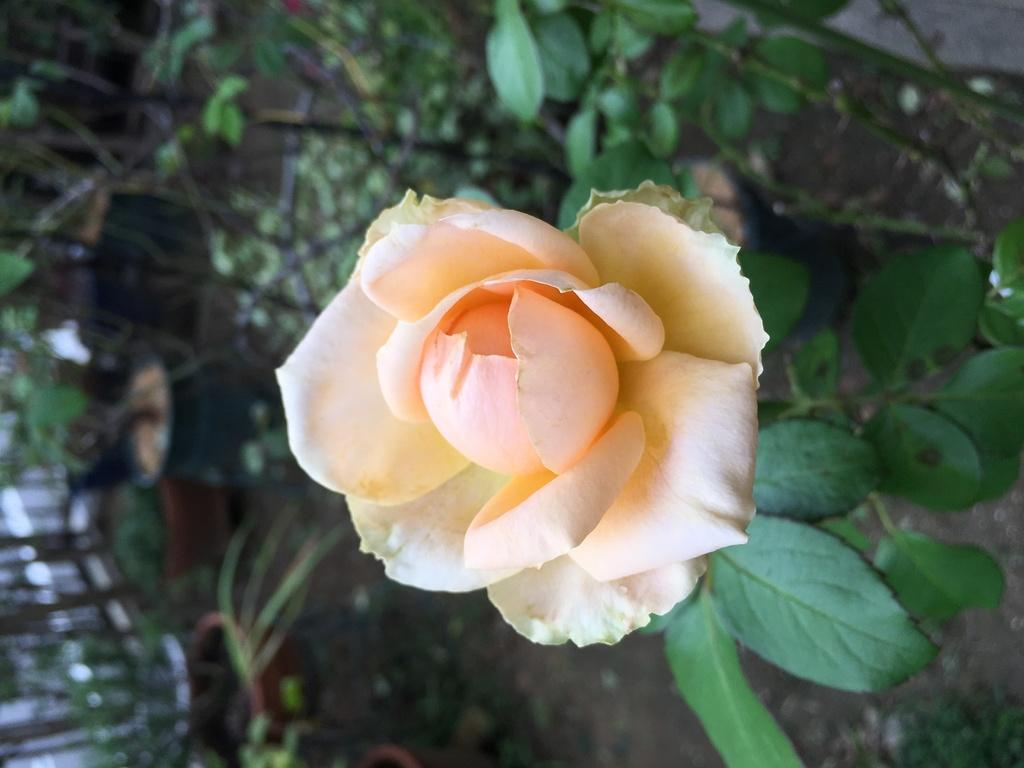What type of flower is in the image? There is a rose flower in the image. What can be seen in the background of the image? There are plants and flower pots in the background of the image. Where is the cave located in the image? There is no cave present in the image. What type of tomatoes are growing in the garden in the image? There is no garden or tomatoes present in the image. 